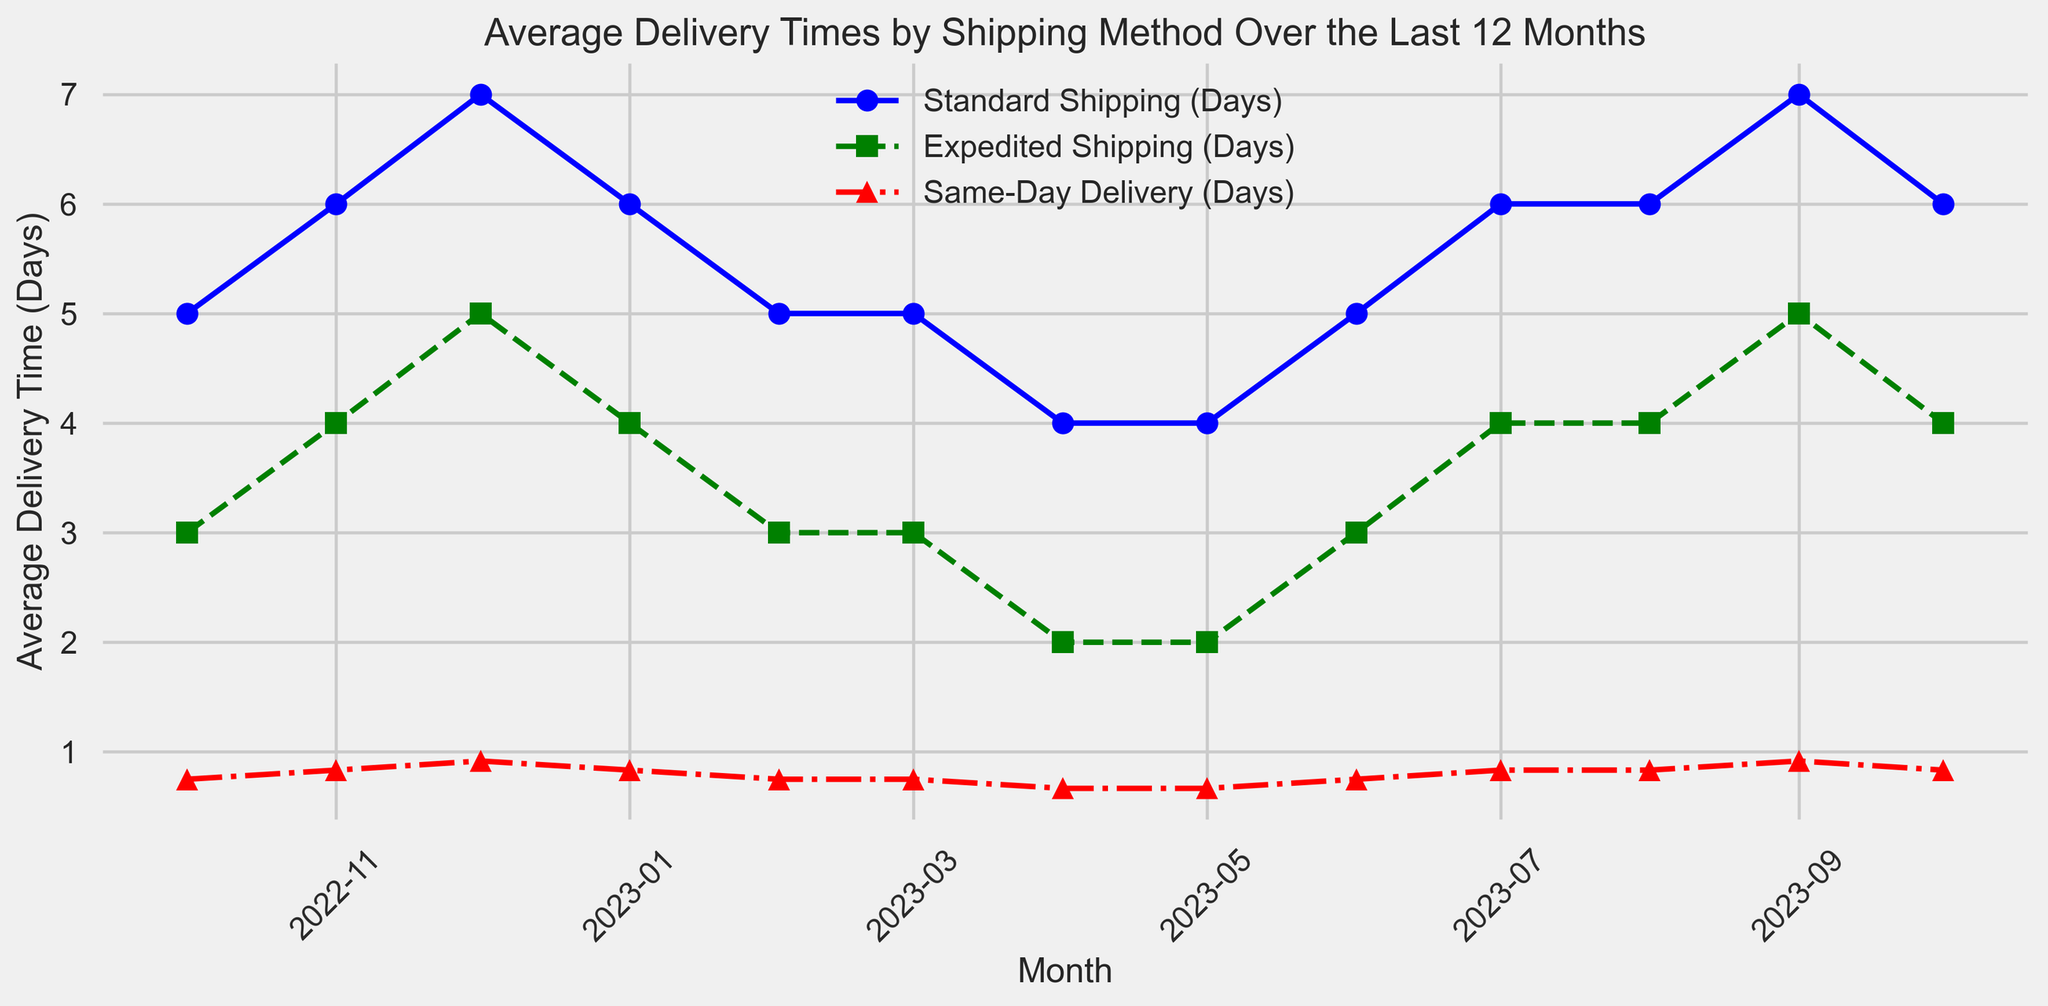What is the average delivery time for Standard Shipping across the year? To find the average, add all the delivery times for Standard Shipping and divide by the number of months. (5 + 6 + 7 + 6 + 5 + 5 + 4 + 4 + 5 + 6 + 6 + 7 + 6) / 13 ≈ 5.62
Answer: 5.62 days Which month had the longest average delivery time for Expedited Shipping? By examining the plot, the month with the highest point for Expedited Shipping is December with 5 days.
Answer: December How does the average delivery time for Same-Day Delivery in September compare to that in October? On the plot, the average delivery time for Same-Day Delivery in September is 22 hours (22/24 days ≈ 0.92 days), and in October is 20 hours (20/24 days ≈ 0.83 days). Therefore, September is longer.
Answer: September is longer In which months did Standard Shipping take 6 days? By locating the points for Standard Shipping at 6 days, the months are November, January, July, August, and October.
Answer: November, January, July, August, October What was the trend for Standard Shipping delivery times from April to July? Standard Shipping delivery times increased from April (4 days) to May (4 days), June (5 days), and peaked in July (6 days).
Answer: Increasing trend Which shipping method showed the greatest improvement between December 2022 and April 2023? By checking the plot, compare initial values in December 2022 and values in April 2023 for each method. Standard Shipping went from 7 to 4 days (improvement of 3 days), Expedited Shipping from 5 to 2 days (improvement of 3 days), Same-Day Delivery from 22 to 16 hours (improvement of 6 hours or 0.25 days). Standard and Expedited have the same improvement.
Answer: Standard and Expedited Shipping What was the average delivery time for Expedited Shipping in the second half of the year? Average delivery time for Expedited Shipping from July to December: (4 + 4 + 5 + 4 + 3 + 3) / 6 = 3.83 days.
Answer: 3.83 days Which shipping method was consistently the fastest throughout the year? By comparing all points in the plot, Same-Day Delivery (converted to days) is consistently the lowest across all months.
Answer: Same-Day Delivery In which month did Standard Shipping and Expedited Shipping have the same average delivery time? By examining the plot, there are no months where Standard and Expedited Shipping are equal. Therefore, none.
Answer: None Was there a month when all shipping methods improved delivery times compared to the previous month? Comparing each month's data, from March to April, Standard Shipping went from 5 to 4 days, Expedited from 3 to 2 days, Same-Day from 18 to 16 hours.
Answer: April 